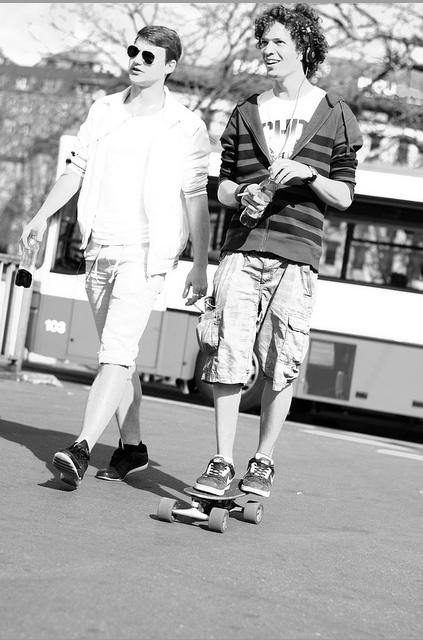What is the person on the left doing? Please explain your reasoning. walking. One person is walking and the other is riding a skateboard. 